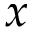Convert formula to latex. <formula><loc_0><loc_0><loc_500><loc_500>x</formula> 